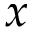Convert formula to latex. <formula><loc_0><loc_0><loc_500><loc_500>x</formula> 